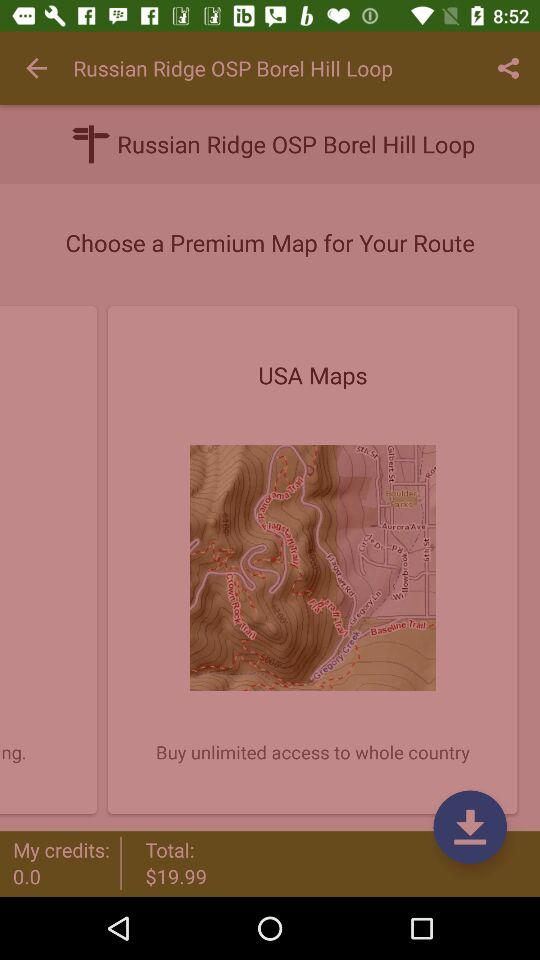How much more does the USA map cost than my current credits?
Answer the question using a single word or phrase. $19.99 